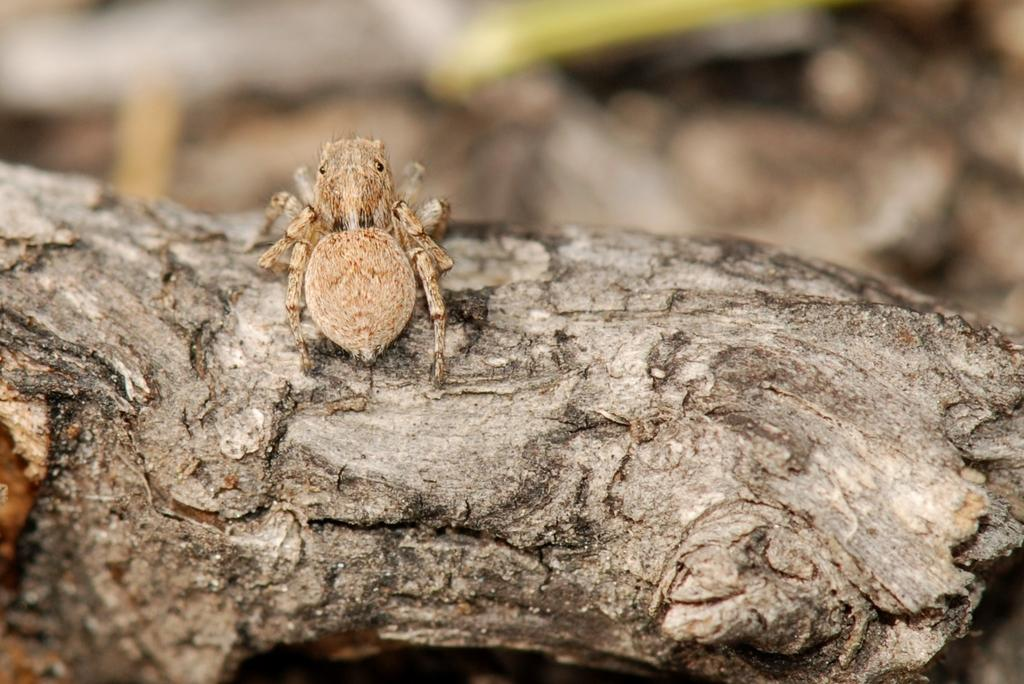What is the main subject of the image? There is an insect in the image. Where is the insect located? The insect is on a wooden branch of a tree. Can you describe the background of the image? The background of the image is blurry. Who is the owner of the insect in the image? There is no indication in the image that the insect has an owner. 